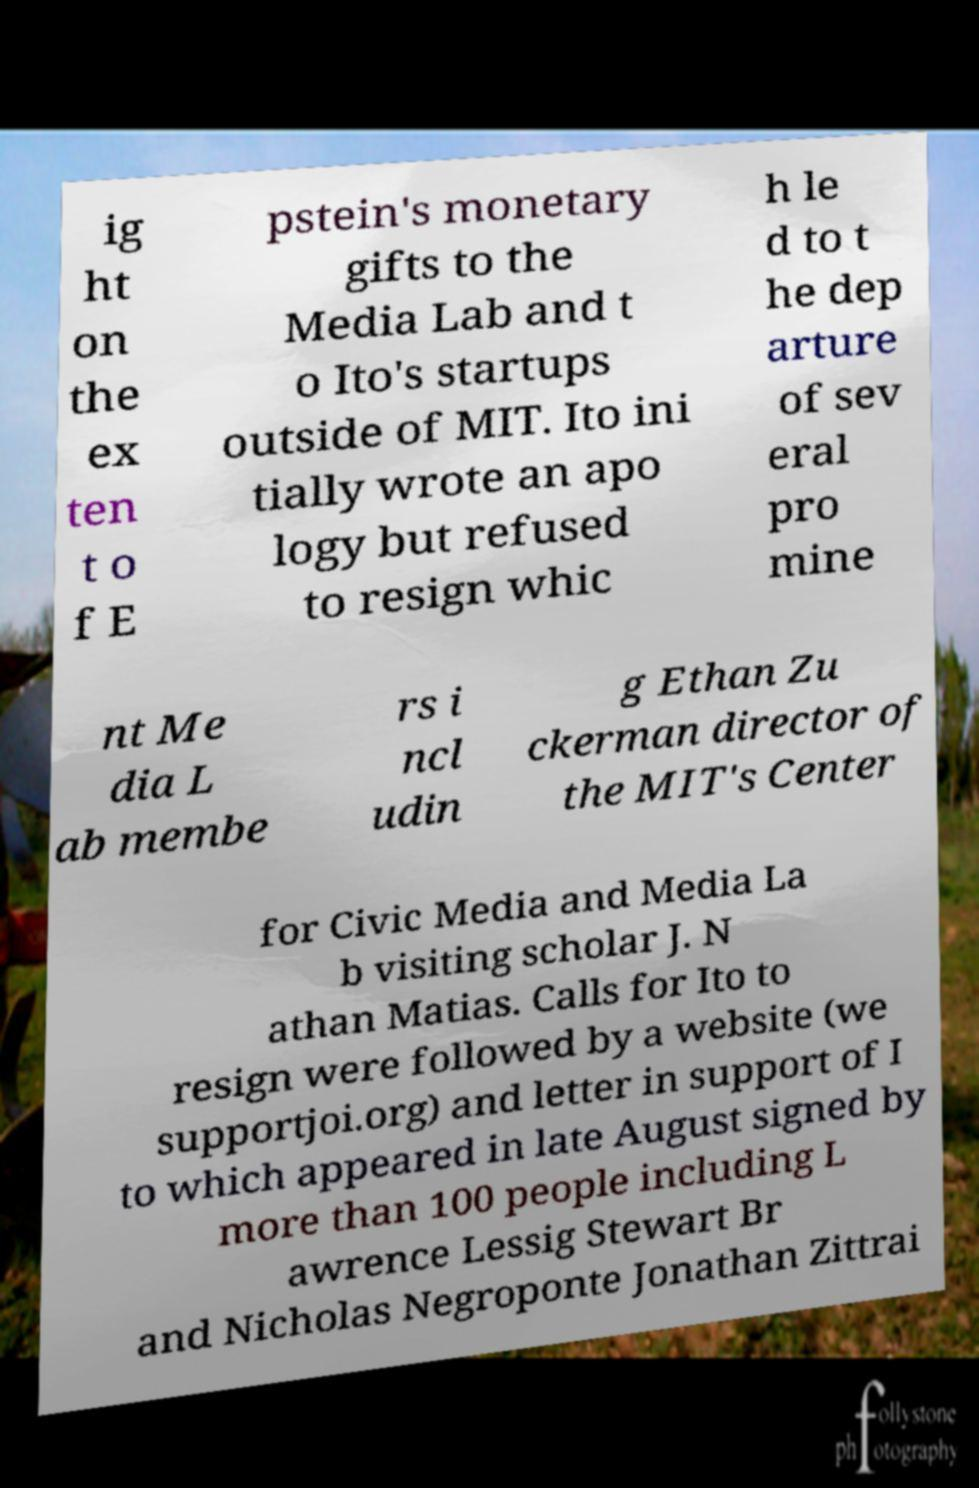Please identify and transcribe the text found in this image. ig ht on the ex ten t o f E pstein's monetary gifts to the Media Lab and t o Ito's startups outside of MIT. Ito ini tially wrote an apo logy but refused to resign whic h le d to t he dep arture of sev eral pro mine nt Me dia L ab membe rs i ncl udin g Ethan Zu ckerman director of the MIT's Center for Civic Media and Media La b visiting scholar J. N athan Matias. Calls for Ito to resign were followed by a website (we supportjoi.org) and letter in support of I to which appeared in late August signed by more than 100 people including L awrence Lessig Stewart Br and Nicholas Negroponte Jonathan Zittrai 